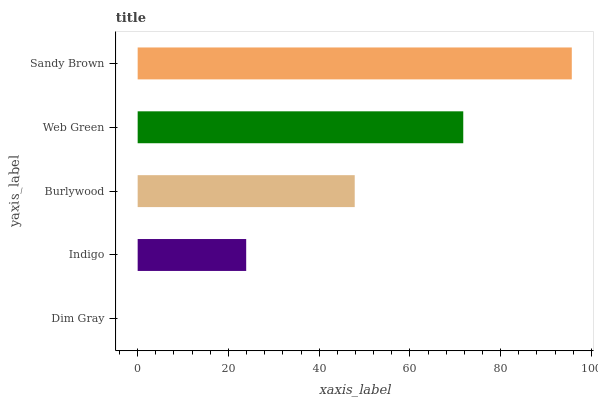Is Dim Gray the minimum?
Answer yes or no. Yes. Is Sandy Brown the maximum?
Answer yes or no. Yes. Is Indigo the minimum?
Answer yes or no. No. Is Indigo the maximum?
Answer yes or no. No. Is Indigo greater than Dim Gray?
Answer yes or no. Yes. Is Dim Gray less than Indigo?
Answer yes or no. Yes. Is Dim Gray greater than Indigo?
Answer yes or no. No. Is Indigo less than Dim Gray?
Answer yes or no. No. Is Burlywood the high median?
Answer yes or no. Yes. Is Burlywood the low median?
Answer yes or no. Yes. Is Indigo the high median?
Answer yes or no. No. Is Web Green the low median?
Answer yes or no. No. 